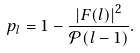Convert formula to latex. <formula><loc_0><loc_0><loc_500><loc_500>p _ { l } = 1 - \frac { \left | F ( l ) \right | ^ { 2 } } { \mathcal { P } ( l - 1 ) } .</formula> 